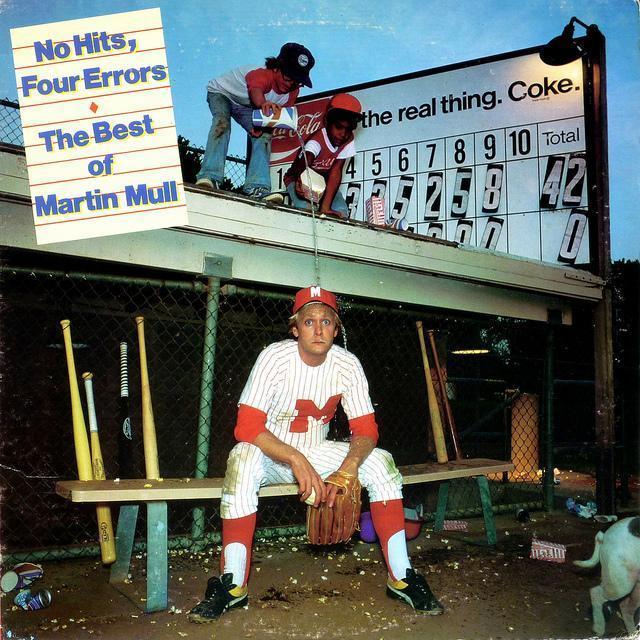How many people are there?
Give a very brief answer. 3. How many baseball bats are in the picture?
Give a very brief answer. 1. How many buses are on the street?
Give a very brief answer. 0. 